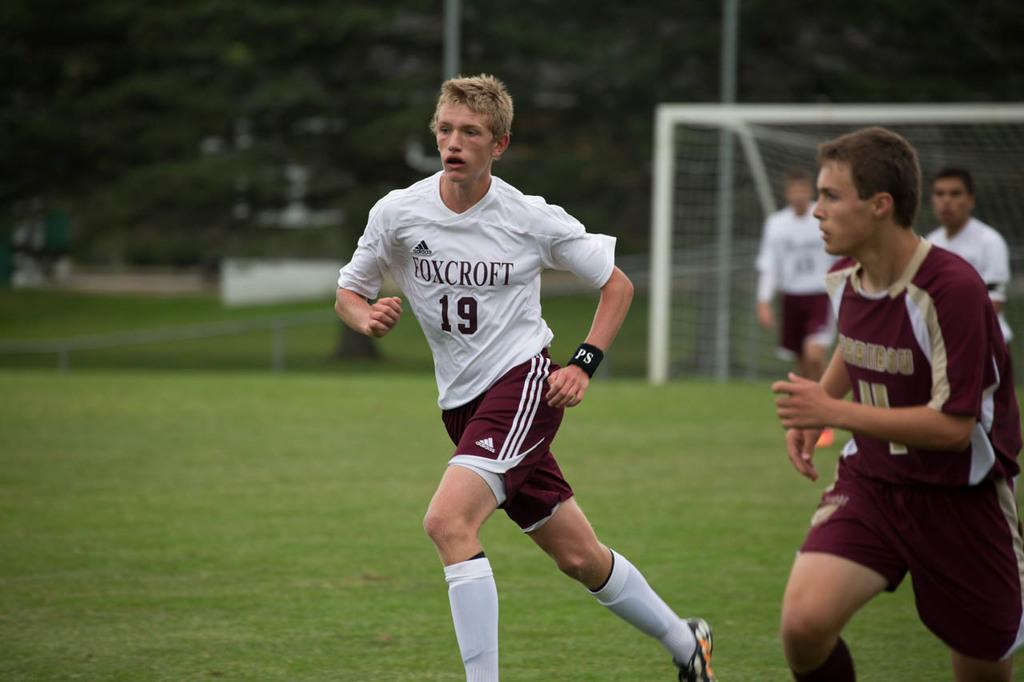<image>
Provide a brief description of the given image. the number 19 is on the soccer player's jersey 